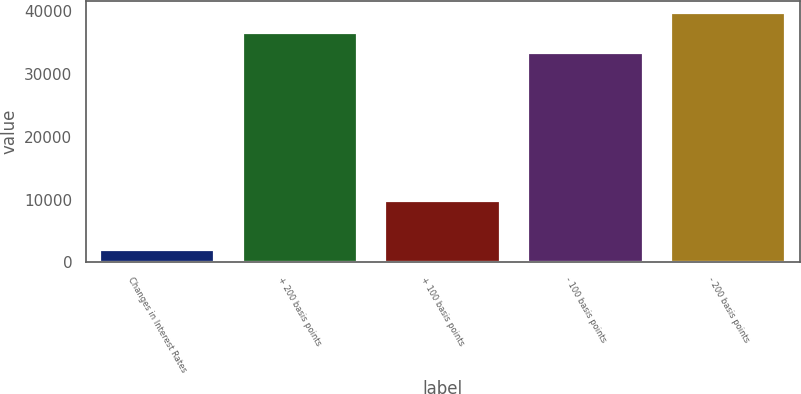<chart> <loc_0><loc_0><loc_500><loc_500><bar_chart><fcel>Changes in Interest Rates<fcel>+ 200 basis points<fcel>+ 100 basis points<fcel>- 100 basis points<fcel>- 200 basis points<nl><fcel>2008<fcel>36497.9<fcel>9726<fcel>33281<fcel>39714.8<nl></chart> 